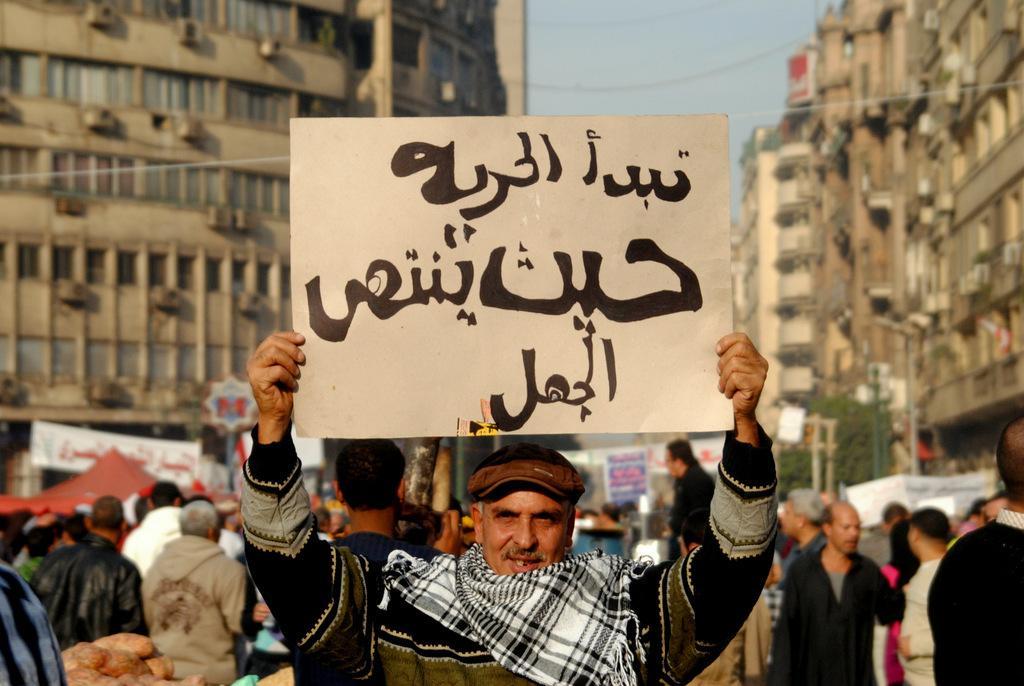Can you describe this image briefly? People are protesting. A person is holding a placard. There are buildings, trees, poles and banners at the back. 